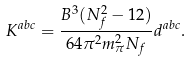<formula> <loc_0><loc_0><loc_500><loc_500>K ^ { a b c } = \frac { B ^ { 3 } ( N _ { f } ^ { 2 } - 1 2 ) } { 6 4 \pi ^ { 2 } m _ { \pi } ^ { 2 } N _ { f } } d ^ { a b c } .</formula> 